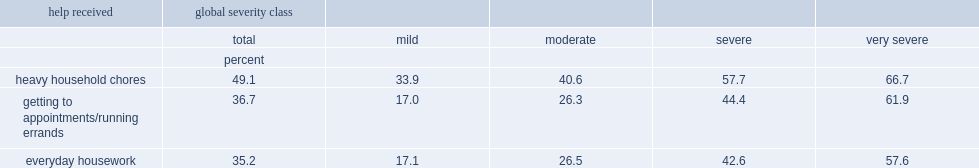Write the full table. {'header': ['help received', 'global severity class', '', '', '', ''], 'rows': [['', 'total', 'mild', 'moderate', 'severe', 'very severe'], ['', 'percent', '', '', '', ''], ['heavy household chores', '49.1', '33.9', '40.6', '57.7', '66.7'], ['getting to appointments/running errands', '36.7', '17.0', '26.3', '44.4', '61.9'], ['everyday housework', '35.2', '17.1', '26.5', '42.6', '57.6']]} What is the percentage of persons who report having received help with heavy household chores overall? 49.1. What is the percentage of persons with mild disabilities who report having received help with heavy household chores? 33.9. What is the percentage of persons with very severe disabilities who report having received help with heavy household chores? 66.7. 